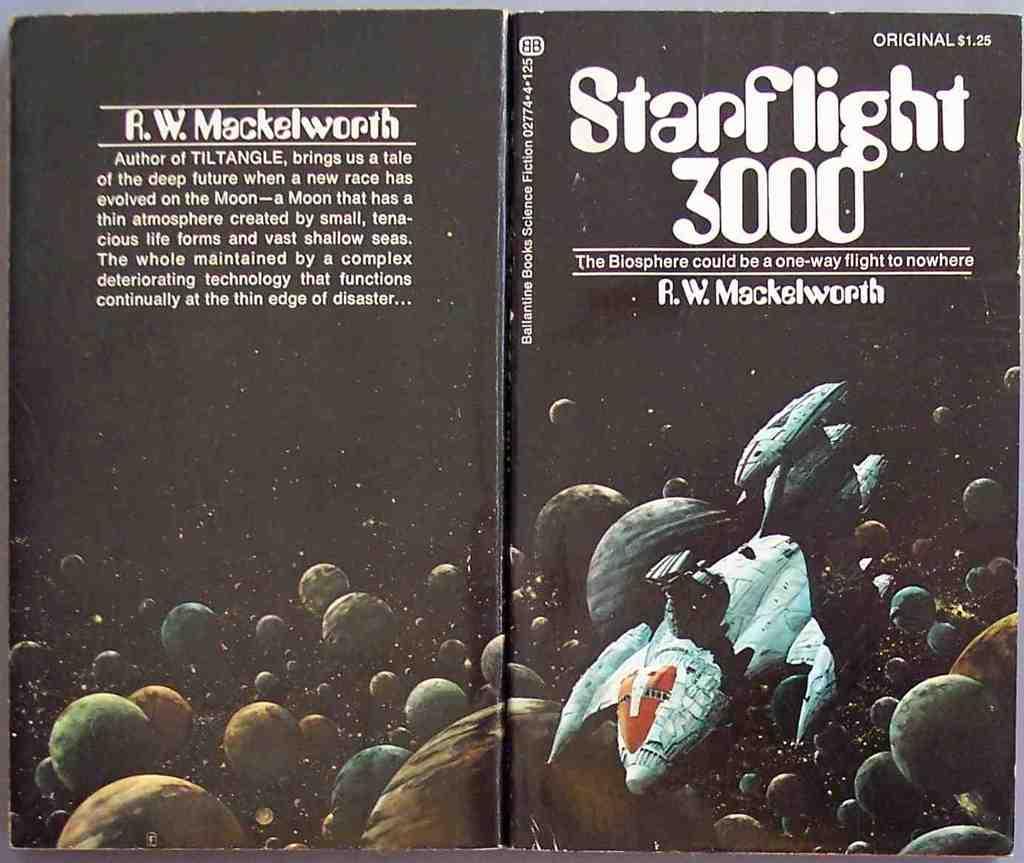Who is the author of this glorious science fiction book?
Give a very brief answer. R.w. mackelworth. What is the title of this book?
Offer a very short reply. Starflight 3000. 